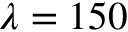<formula> <loc_0><loc_0><loc_500><loc_500>\lambda = 1 5 0</formula> 